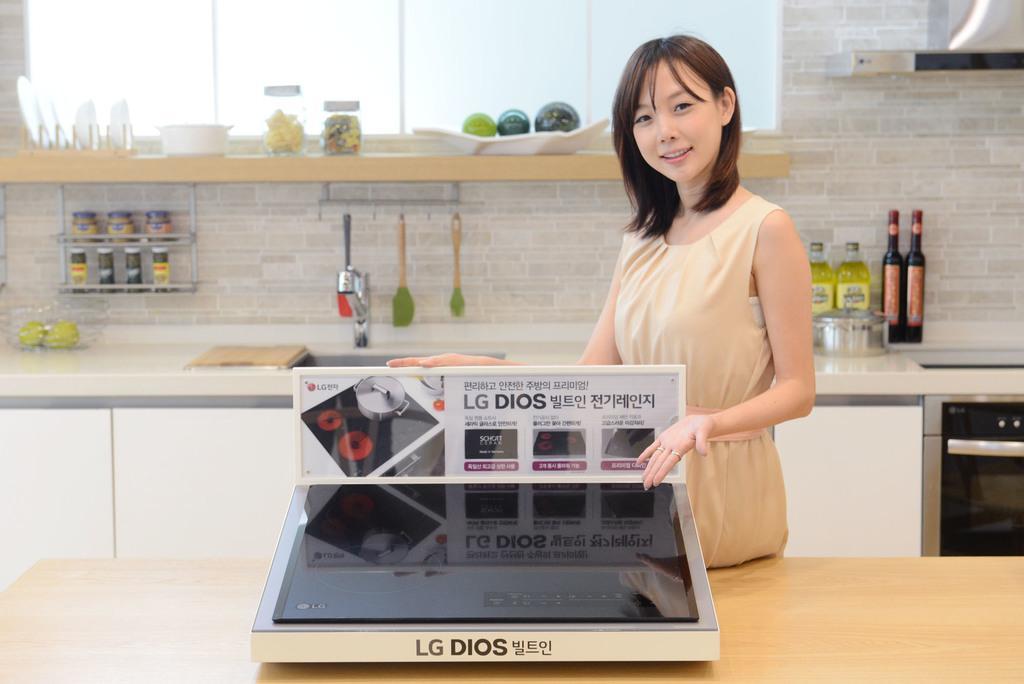Can you describe this image briefly? Here we can see a woman standing on the right side and she is showing an electronic device. In the background we can see a oil bottles and a sink. 